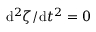Convert formula to latex. <formula><loc_0><loc_0><loc_500><loc_500>d ^ { 2 } \zeta / d t ^ { 2 } = 0</formula> 